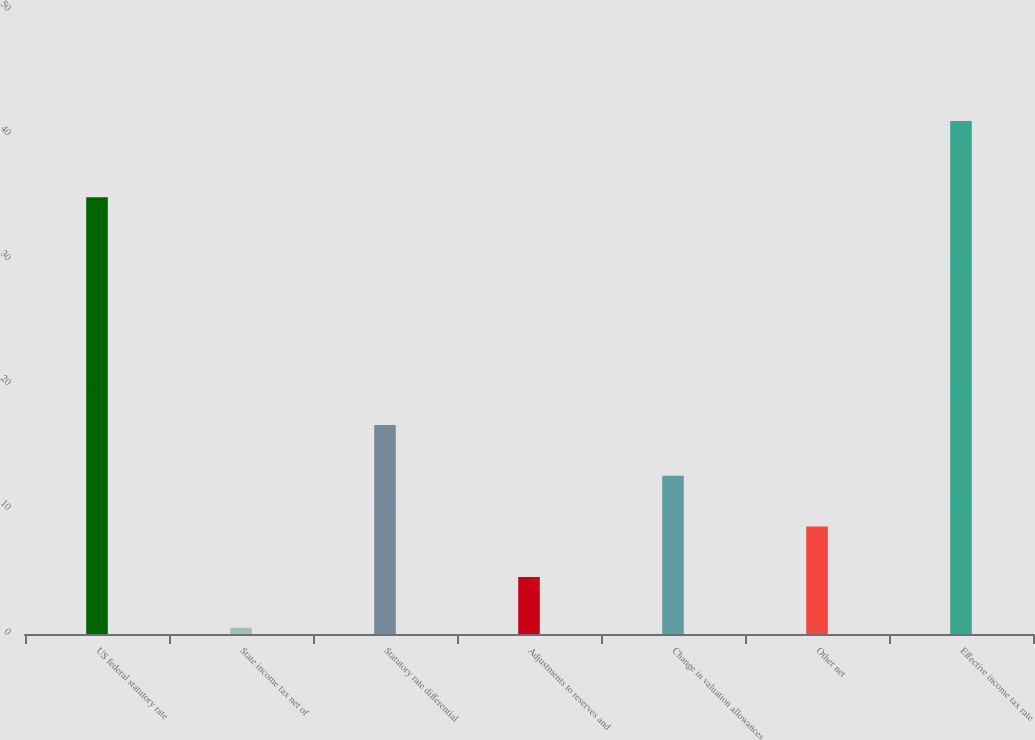Convert chart to OTSL. <chart><loc_0><loc_0><loc_500><loc_500><bar_chart><fcel>US federal statutory rate<fcel>State income tax net of<fcel>Statutory rate differential<fcel>Adjustments to reserves and<fcel>Change in valuation allowances<fcel>Other net<fcel>Effective income tax rate<nl><fcel>35<fcel>0.5<fcel>16.74<fcel>4.56<fcel>12.68<fcel>8.62<fcel>41.1<nl></chart> 